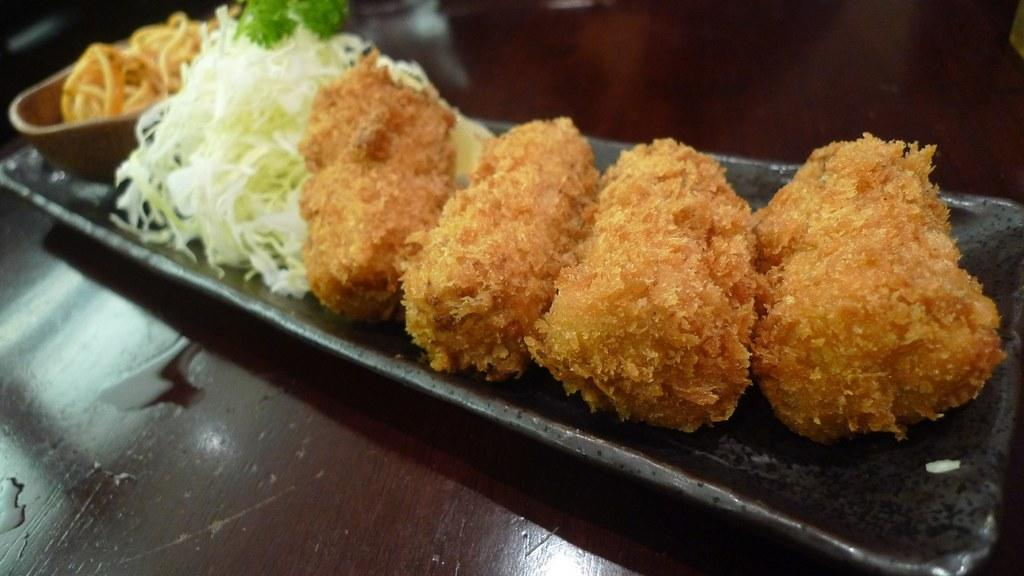What type of items can be seen in the image? There are eatable items in the image. Where are the eatable items located? The eatable items are placed on a table. What type of scent can be smelled from the eatable items in the image? There is no information about the scent of the eatable items in the image, so it cannot be determined. 